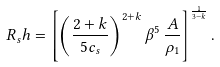<formula> <loc_0><loc_0><loc_500><loc_500>R _ { s } h = \left [ \left ( \frac { 2 + k } { 5 c _ { s } } \right ) ^ { 2 + k } \beta ^ { 5 } \, \frac { A } { \rho _ { 1 } } \right ] ^ { \frac { 1 } { 3 - k } } .</formula> 